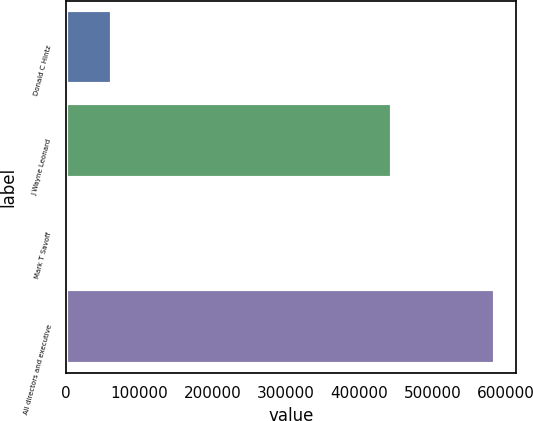Convert chart. <chart><loc_0><loc_0><loc_500><loc_500><bar_chart><fcel>Donald C Hintz<fcel>J Wayne Leonard<fcel>Mark T Savoff<fcel>All directors and executive<nl><fcel>62443.7<fcel>444898<fcel>4363<fcel>585170<nl></chart> 